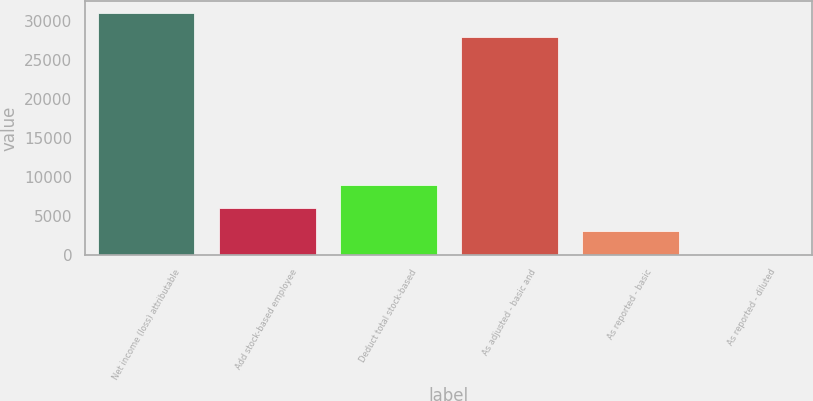Convert chart. <chart><loc_0><loc_0><loc_500><loc_500><bar_chart><fcel>Net income (loss) attributable<fcel>Add stock-based employee<fcel>Deduct total stock-based<fcel>As adjusted - basic and<fcel>As reported - basic<fcel>As reported - diluted<nl><fcel>30955.7<fcel>5911.6<fcel>8867.28<fcel>28000<fcel>2955.93<fcel>0.25<nl></chart> 